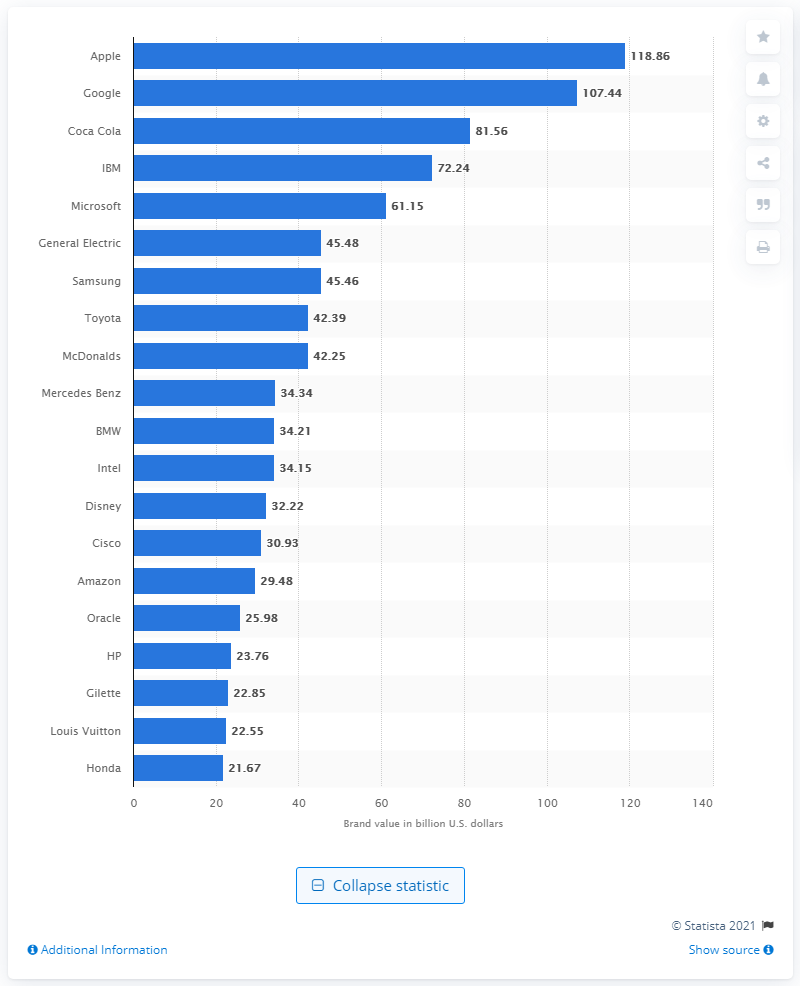Specify some key components in this picture. In 2014, Coca-Cola was the world's third most valuable brand. In 2014, Coca-Cola's brand value in the United States was estimated to be 81.56 dollars. 